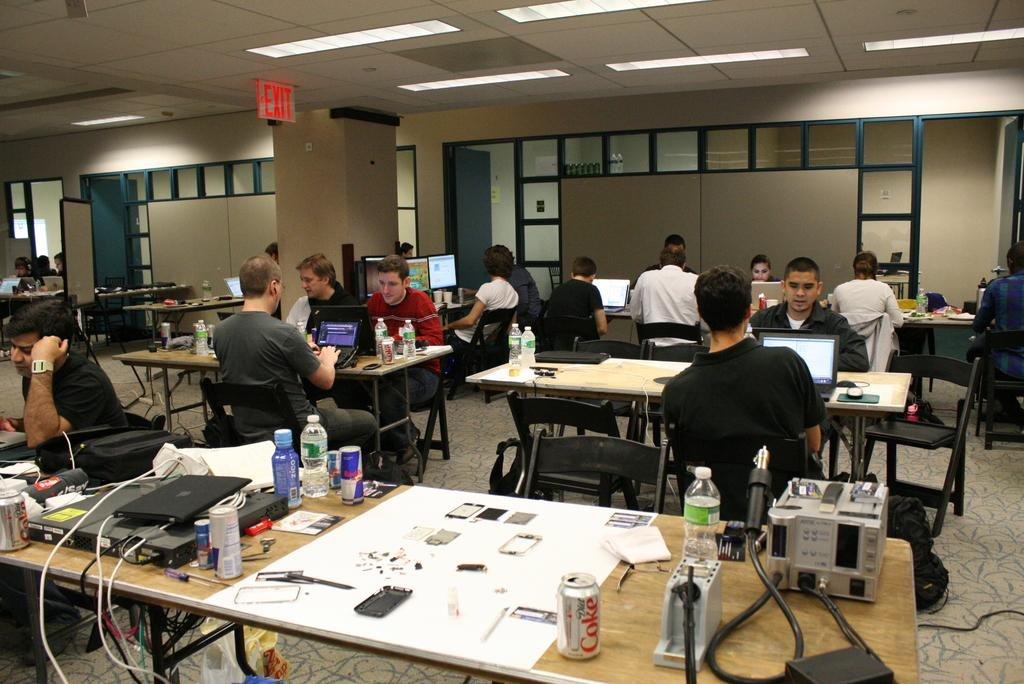How many people are in the image? There is a group of people in the image. What are the people doing in the image? The people are seated on chairs. What are some of the people using in the image? Some people are using laptops. What can be seen on the table in the image? There are water bottles, Coke cans, and papers on the table. What type of shoes are the people wearing in the image? There is no information about shoes in the image; the focus is on the people seated on chairs and using laptops. 